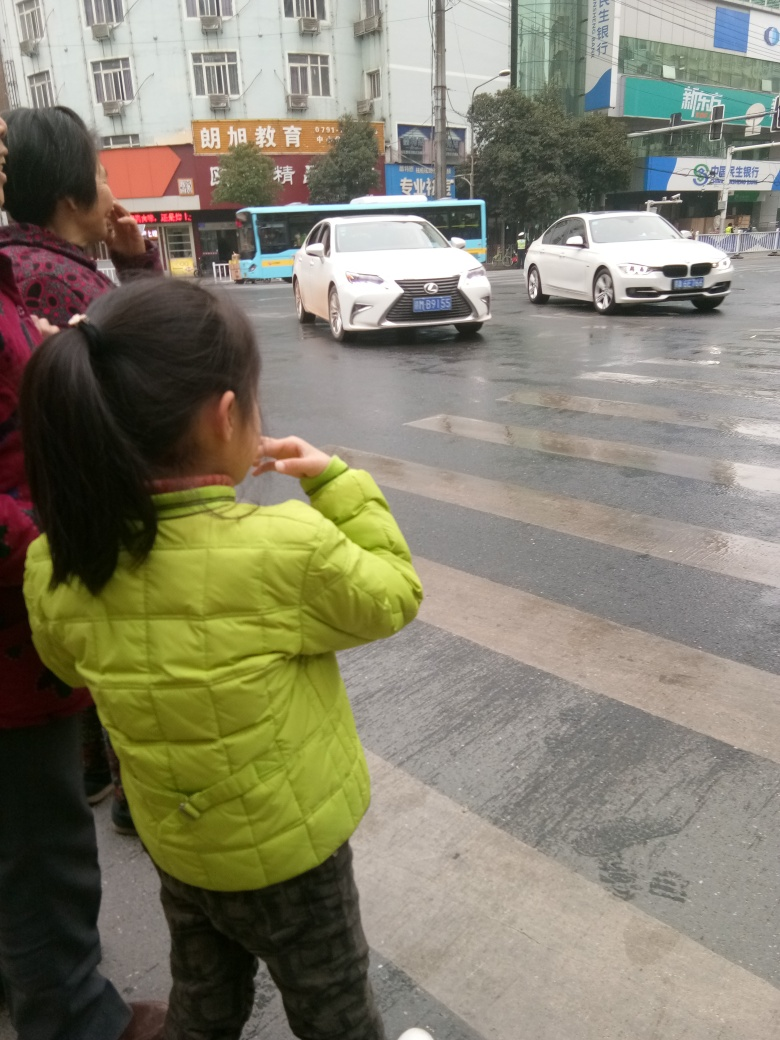Can you comment on the different modes of transportation visible in the image? Certainly, we have a combination of private and public transportation. There's a bus in the background representing public transit, while the cars in the foreground are private vehicles. This variety indicates a multimodal transport system which could facilitate the movement of people in various socioeconomic segments. How do these varied modes of transportation reflect on the city's traffic management system? A diverse mix of transportation indicates an attempt to balance the traffic flow and reduce congestion. Effective traffic management would aim to integrate different transport modes smoothly, reducing delays and optimizing the use of roads. Monitoring systems and traffic signals tailored to the flow of both public and private vehicles are key for efficiency. 